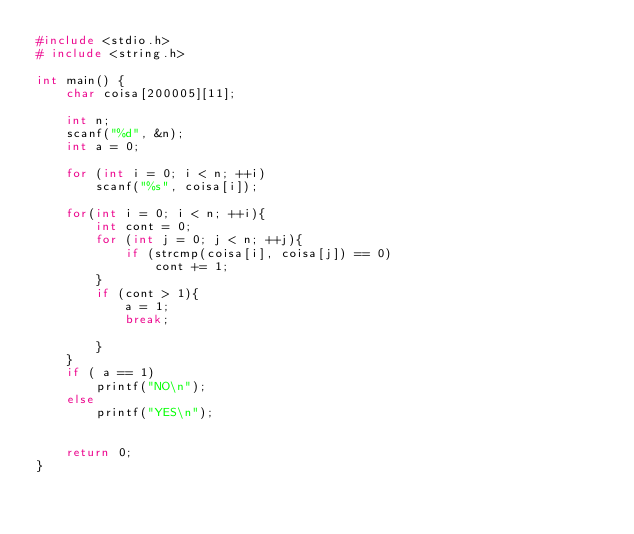Convert code to text. <code><loc_0><loc_0><loc_500><loc_500><_C_>#include <stdio.h>
# include <string.h>

int main() {
    char coisa[200005][11];
    
    int n;
    scanf("%d", &n);
    int a = 0;
    
    for (int i = 0; i < n; ++i)
        scanf("%s", coisa[i]);
        
    for(int i = 0; i < n; ++i){
        int cont = 0;
        for (int j = 0; j < n; ++j){
            if (strcmp(coisa[i], coisa[j]) == 0)
                cont += 1;
        }
        if (cont > 1){
            a = 1;
            break;
            
        }
    }
    if ( a == 1)
        printf("NO\n");
    else
        printf("YES\n");
    
    
    return 0;
}
</code> 